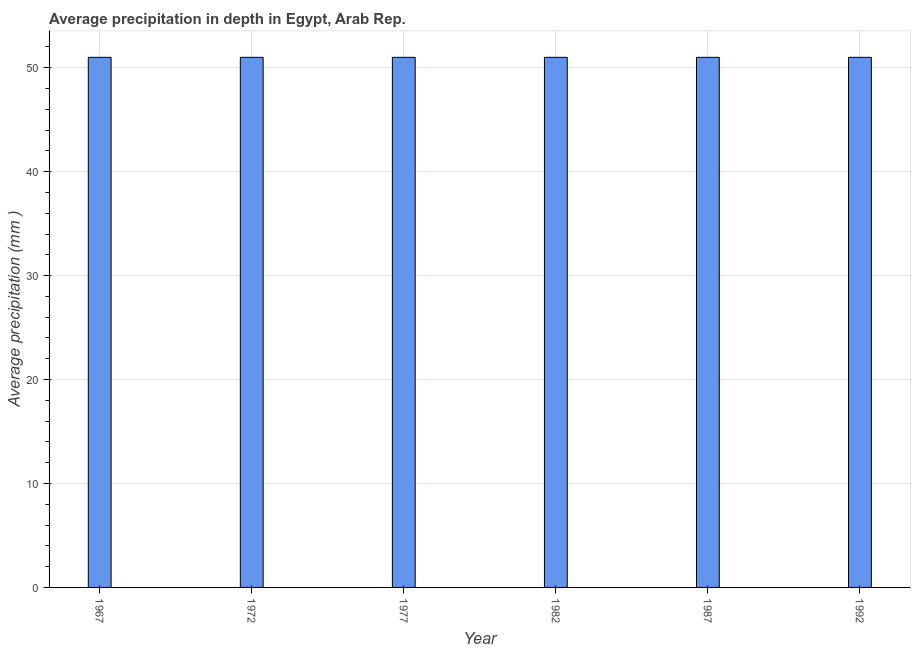Does the graph contain grids?
Offer a terse response. Yes. What is the title of the graph?
Offer a terse response. Average precipitation in depth in Egypt, Arab Rep. What is the label or title of the X-axis?
Ensure brevity in your answer.  Year. What is the label or title of the Y-axis?
Give a very brief answer. Average precipitation (mm ). What is the average precipitation in depth in 1967?
Give a very brief answer. 51. Across all years, what is the maximum average precipitation in depth?
Provide a succinct answer. 51. Across all years, what is the minimum average precipitation in depth?
Your answer should be very brief. 51. In which year was the average precipitation in depth maximum?
Ensure brevity in your answer.  1967. In which year was the average precipitation in depth minimum?
Keep it short and to the point. 1967. What is the sum of the average precipitation in depth?
Give a very brief answer. 306. What is the average average precipitation in depth per year?
Offer a very short reply. 51. What is the median average precipitation in depth?
Provide a short and direct response. 51. In how many years, is the average precipitation in depth greater than 46 mm?
Offer a terse response. 6. Do a majority of the years between 1977 and 1967 (inclusive) have average precipitation in depth greater than 36 mm?
Give a very brief answer. Yes. What is the ratio of the average precipitation in depth in 1967 to that in 1977?
Offer a terse response. 1. Is the average precipitation in depth in 1972 less than that in 1992?
Your response must be concise. No. What is the difference between the highest and the lowest average precipitation in depth?
Your answer should be very brief. 0. In how many years, is the average precipitation in depth greater than the average average precipitation in depth taken over all years?
Your answer should be compact. 0. Are all the bars in the graph horizontal?
Make the answer very short. No. How many years are there in the graph?
Keep it short and to the point. 6. Are the values on the major ticks of Y-axis written in scientific E-notation?
Provide a succinct answer. No. What is the Average precipitation (mm ) in 1972?
Your response must be concise. 51. What is the Average precipitation (mm ) in 1977?
Offer a terse response. 51. What is the Average precipitation (mm ) of 1987?
Offer a very short reply. 51. What is the Average precipitation (mm ) in 1992?
Your answer should be compact. 51. What is the difference between the Average precipitation (mm ) in 1967 and 1977?
Keep it short and to the point. 0. What is the difference between the Average precipitation (mm ) in 1967 and 1987?
Offer a terse response. 0. What is the difference between the Average precipitation (mm ) in 1967 and 1992?
Provide a succinct answer. 0. What is the difference between the Average precipitation (mm ) in 1972 and 1977?
Offer a very short reply. 0. What is the difference between the Average precipitation (mm ) in 1972 and 1982?
Offer a terse response. 0. What is the difference between the Average precipitation (mm ) in 1972 and 1992?
Your answer should be compact. 0. What is the difference between the Average precipitation (mm ) in 1982 and 1987?
Offer a very short reply. 0. What is the difference between the Average precipitation (mm ) in 1987 and 1992?
Offer a very short reply. 0. What is the ratio of the Average precipitation (mm ) in 1967 to that in 1977?
Ensure brevity in your answer.  1. What is the ratio of the Average precipitation (mm ) in 1967 to that in 1992?
Provide a short and direct response. 1. What is the ratio of the Average precipitation (mm ) in 1972 to that in 1977?
Your response must be concise. 1. What is the ratio of the Average precipitation (mm ) in 1972 to that in 1982?
Ensure brevity in your answer.  1. What is the ratio of the Average precipitation (mm ) in 1972 to that in 1992?
Your response must be concise. 1. What is the ratio of the Average precipitation (mm ) in 1977 to that in 1982?
Ensure brevity in your answer.  1. What is the ratio of the Average precipitation (mm ) in 1982 to that in 1987?
Provide a short and direct response. 1. 